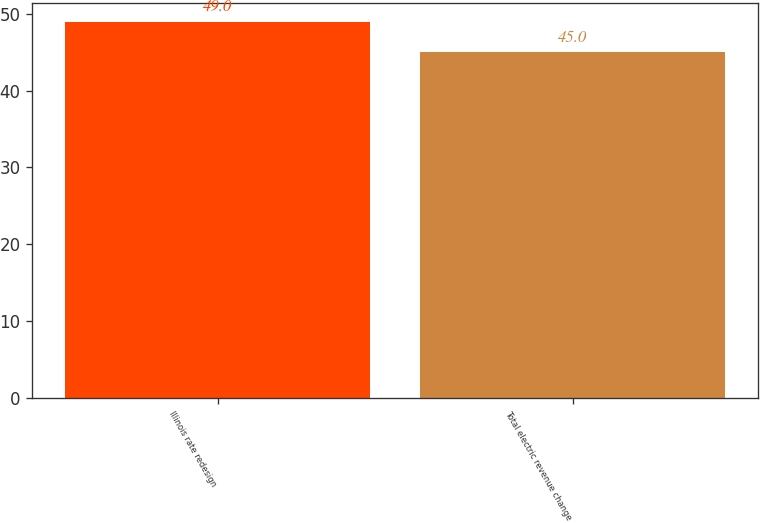<chart> <loc_0><loc_0><loc_500><loc_500><bar_chart><fcel>Illinois rate redesign<fcel>Total electric revenue change<nl><fcel>49<fcel>45<nl></chart> 